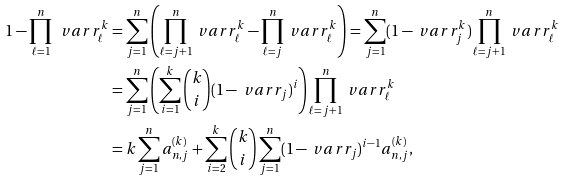<formula> <loc_0><loc_0><loc_500><loc_500>1 - \prod _ { \ell = 1 } ^ { n } \ v a r r ^ { k } _ { \ell } & = \sum _ { j = 1 } ^ { n } \left ( \prod _ { \ell = j + 1 } ^ { n } \ v a r r ^ { k } _ { \ell } - \prod _ { \ell = j } ^ { n } \ v a r r ^ { k } _ { \ell } \right ) = \sum _ { j = 1 } ^ { n } ( 1 - \ v a r r ^ { k } _ { j } ) \prod _ { \ell = j + 1 } ^ { n } \ v a r r ^ { k } _ { \ell } \\ & = \sum _ { j = 1 } ^ { n } \left ( \sum _ { i = 1 } ^ { k } \binom { k } { i } ( 1 - \ v a r r _ { j } ) ^ { i } \right ) \prod _ { \ell = j + 1 } ^ { n } \ v a r r ^ { k } _ { \ell } \\ & = k \sum _ { j = 1 } ^ { n } a ^ { ( k ) } _ { n , j } + \sum _ { i = 2 } ^ { k } \binom { k } { i } \sum _ { j = 1 } ^ { n } ( 1 - \ v a r r _ { j } ) ^ { i - 1 } a ^ { ( k ) } _ { n , j } ,</formula> 